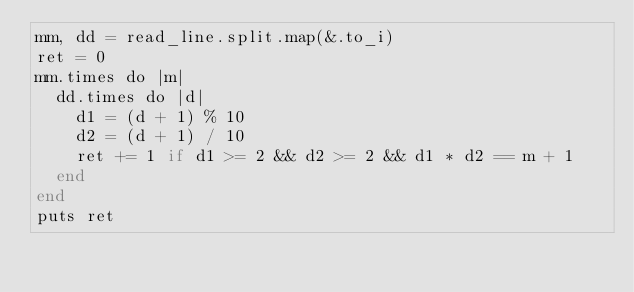Convert code to text. <code><loc_0><loc_0><loc_500><loc_500><_Crystal_>mm, dd = read_line.split.map(&.to_i)
ret = 0
mm.times do |m|
  dd.times do |d|
    d1 = (d + 1) % 10
    d2 = (d + 1) / 10
    ret += 1 if d1 >= 2 && d2 >= 2 && d1 * d2 == m + 1
  end
end
puts ret</code> 